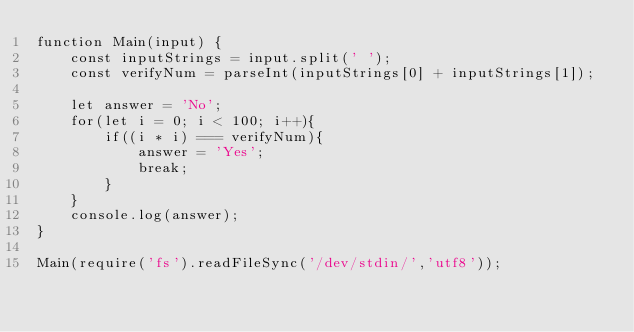Convert code to text. <code><loc_0><loc_0><loc_500><loc_500><_TypeScript_>function Main(input) {
	const inputStrings = input.split(' ');
	const verifyNum = parseInt(inputStrings[0] + inputStrings[1]);
	
	let answer = 'No';
	for(let i = 0; i < 100; i++){
		if((i * i) === verifyNum){
			answer = 'Yes';
			break;
		}
	}
	console.log(answer);
}

Main(require('fs').readFileSync('/dev/stdin/','utf8'));</code> 